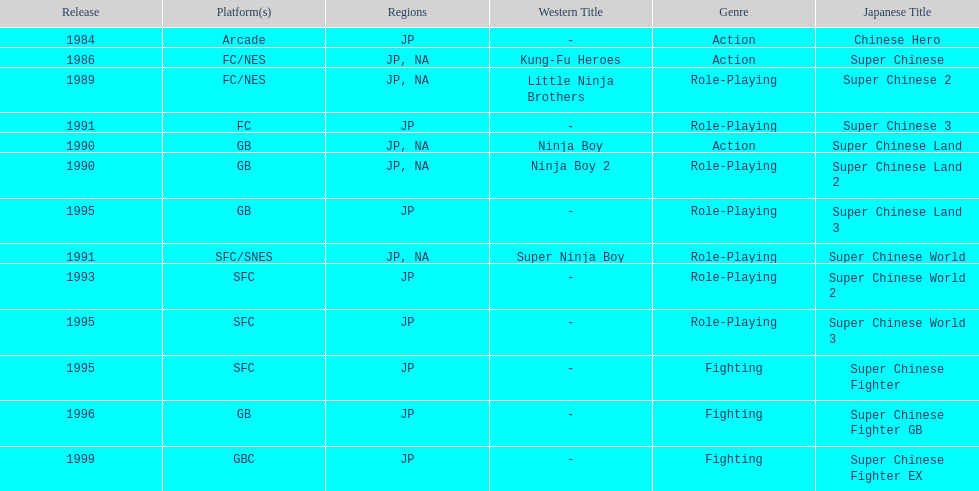Number of super chinese world games released 3. 